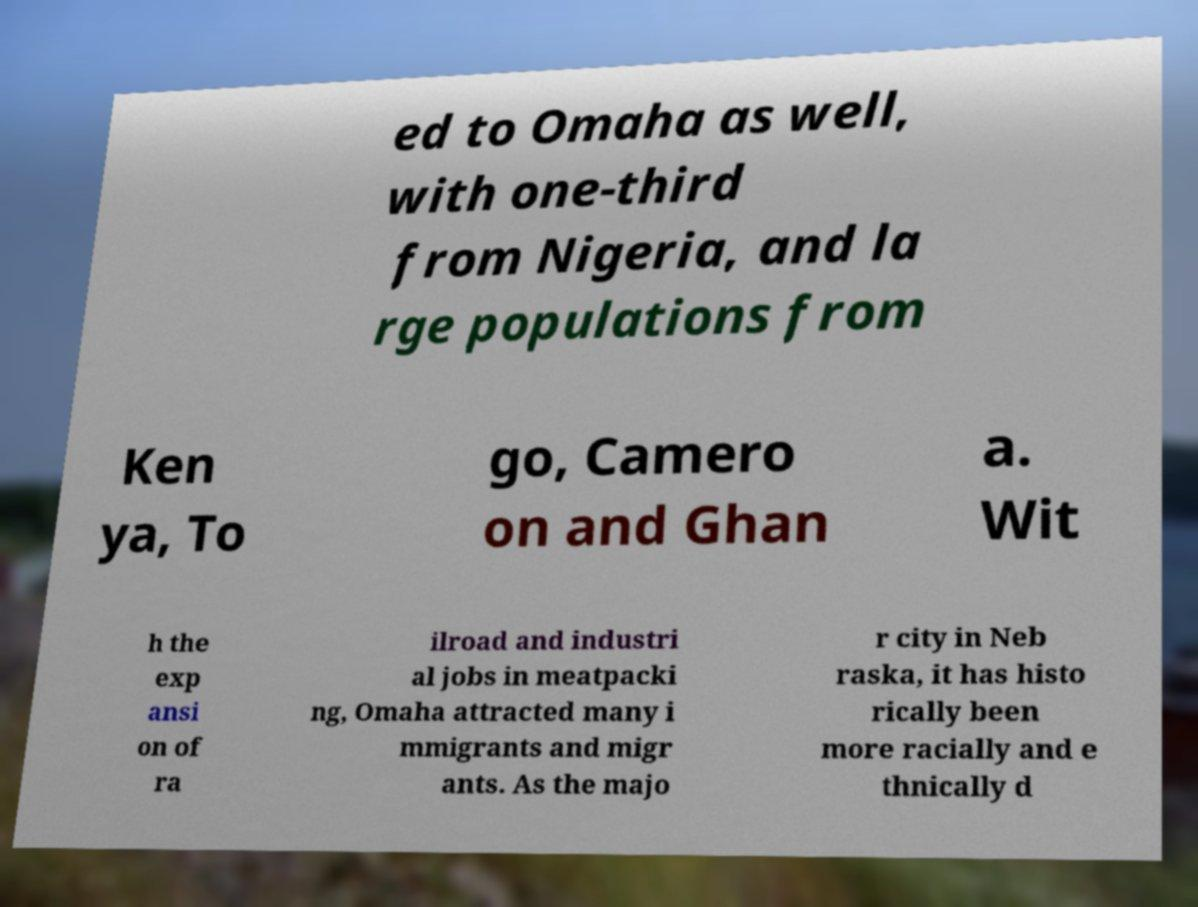Please read and relay the text visible in this image. What does it say? ed to Omaha as well, with one-third from Nigeria, and la rge populations from Ken ya, To go, Camero on and Ghan a. Wit h the exp ansi on of ra ilroad and industri al jobs in meatpacki ng, Omaha attracted many i mmigrants and migr ants. As the majo r city in Neb raska, it has histo rically been more racially and e thnically d 